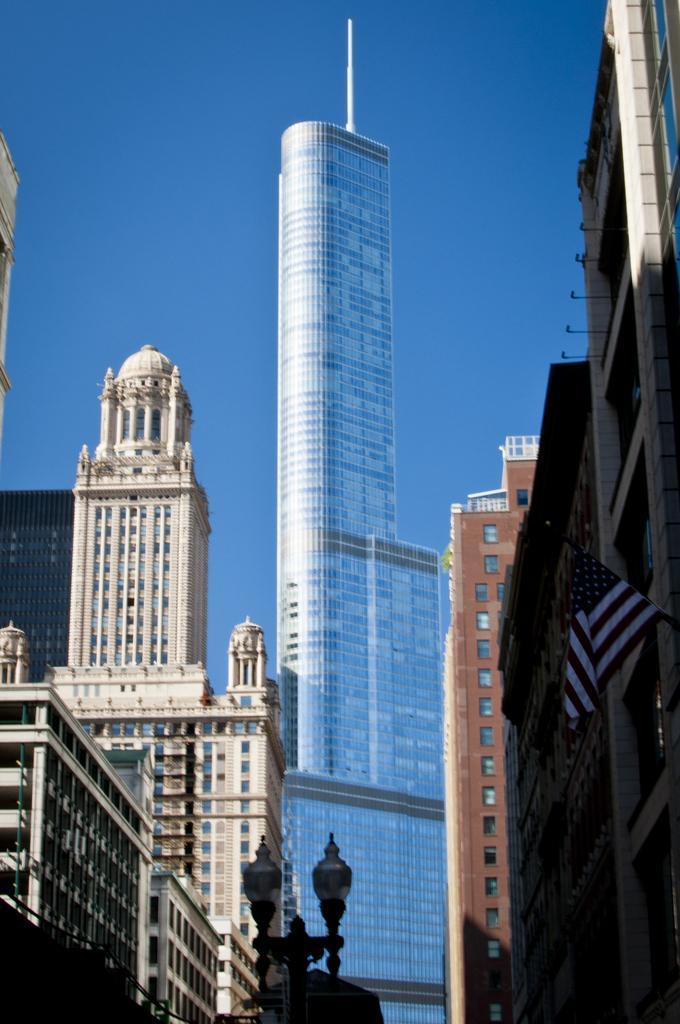Describe this image in one or two sentences. This picture contains many buildings which are in white, blue and brown color. On the right corner of the picture, we see a flag which is in red, white and blue color. At the bottom of the picture, there are street lights and at the top of the picture, we see the sky. It is a sunny day. 